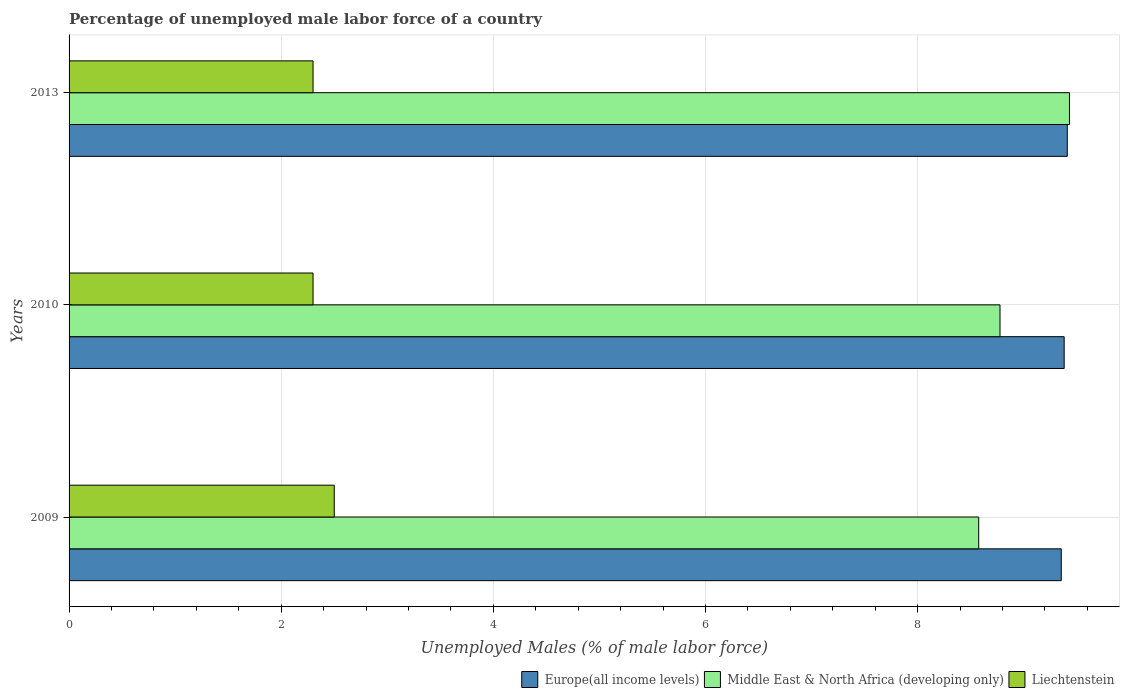How many groups of bars are there?
Offer a terse response. 3. Are the number of bars per tick equal to the number of legend labels?
Provide a succinct answer. Yes. Are the number of bars on each tick of the Y-axis equal?
Ensure brevity in your answer.  Yes. How many bars are there on the 3rd tick from the bottom?
Ensure brevity in your answer.  3. In how many cases, is the number of bars for a given year not equal to the number of legend labels?
Offer a very short reply. 0. What is the percentage of unemployed male labor force in Europe(all income levels) in 2010?
Make the answer very short. 9.38. Across all years, what is the maximum percentage of unemployed male labor force in Middle East & North Africa (developing only)?
Provide a succinct answer. 9.43. Across all years, what is the minimum percentage of unemployed male labor force in Europe(all income levels)?
Your answer should be compact. 9.35. In which year was the percentage of unemployed male labor force in Middle East & North Africa (developing only) minimum?
Provide a succinct answer. 2009. What is the total percentage of unemployed male labor force in Europe(all income levels) in the graph?
Make the answer very short. 28.14. What is the difference between the percentage of unemployed male labor force in Middle East & North Africa (developing only) in 2010 and that in 2013?
Offer a very short reply. -0.65. What is the difference between the percentage of unemployed male labor force in Middle East & North Africa (developing only) in 2010 and the percentage of unemployed male labor force in Europe(all income levels) in 2013?
Ensure brevity in your answer.  -0.63. What is the average percentage of unemployed male labor force in Liechtenstein per year?
Make the answer very short. 2.37. In the year 2010, what is the difference between the percentage of unemployed male labor force in Europe(all income levels) and percentage of unemployed male labor force in Middle East & North Africa (developing only)?
Your answer should be compact. 0.61. What is the ratio of the percentage of unemployed male labor force in Europe(all income levels) in 2009 to that in 2010?
Your answer should be compact. 1. Is the percentage of unemployed male labor force in Europe(all income levels) in 2010 less than that in 2013?
Provide a short and direct response. Yes. Is the difference between the percentage of unemployed male labor force in Europe(all income levels) in 2010 and 2013 greater than the difference between the percentage of unemployed male labor force in Middle East & North Africa (developing only) in 2010 and 2013?
Your answer should be very brief. Yes. What is the difference between the highest and the second highest percentage of unemployed male labor force in Middle East & North Africa (developing only)?
Ensure brevity in your answer.  0.65. What is the difference between the highest and the lowest percentage of unemployed male labor force in Liechtenstein?
Your response must be concise. 0.2. What does the 2nd bar from the top in 2009 represents?
Provide a succinct answer. Middle East & North Africa (developing only). What does the 1st bar from the bottom in 2009 represents?
Offer a very short reply. Europe(all income levels). How many bars are there?
Ensure brevity in your answer.  9. How many years are there in the graph?
Provide a short and direct response. 3. Where does the legend appear in the graph?
Your answer should be compact. Bottom right. What is the title of the graph?
Offer a terse response. Percentage of unemployed male labor force of a country. What is the label or title of the X-axis?
Provide a succinct answer. Unemployed Males (% of male labor force). What is the Unemployed Males (% of male labor force) of Europe(all income levels) in 2009?
Provide a succinct answer. 9.35. What is the Unemployed Males (% of male labor force) in Middle East & North Africa (developing only) in 2009?
Your response must be concise. 8.58. What is the Unemployed Males (% of male labor force) in Liechtenstein in 2009?
Your answer should be very brief. 2.5. What is the Unemployed Males (% of male labor force) in Europe(all income levels) in 2010?
Your answer should be compact. 9.38. What is the Unemployed Males (% of male labor force) in Middle East & North Africa (developing only) in 2010?
Give a very brief answer. 8.78. What is the Unemployed Males (% of male labor force) in Liechtenstein in 2010?
Provide a succinct answer. 2.3. What is the Unemployed Males (% of male labor force) in Europe(all income levels) in 2013?
Your answer should be compact. 9.41. What is the Unemployed Males (% of male labor force) of Middle East & North Africa (developing only) in 2013?
Make the answer very short. 9.43. What is the Unemployed Males (% of male labor force) of Liechtenstein in 2013?
Provide a short and direct response. 2.3. Across all years, what is the maximum Unemployed Males (% of male labor force) of Europe(all income levels)?
Give a very brief answer. 9.41. Across all years, what is the maximum Unemployed Males (% of male labor force) in Middle East & North Africa (developing only)?
Provide a succinct answer. 9.43. Across all years, what is the minimum Unemployed Males (% of male labor force) of Europe(all income levels)?
Give a very brief answer. 9.35. Across all years, what is the minimum Unemployed Males (% of male labor force) of Middle East & North Africa (developing only)?
Give a very brief answer. 8.58. Across all years, what is the minimum Unemployed Males (% of male labor force) of Liechtenstein?
Provide a succinct answer. 2.3. What is the total Unemployed Males (% of male labor force) of Europe(all income levels) in the graph?
Your answer should be compact. 28.14. What is the total Unemployed Males (% of male labor force) of Middle East & North Africa (developing only) in the graph?
Provide a short and direct response. 26.78. What is the total Unemployed Males (% of male labor force) of Liechtenstein in the graph?
Keep it short and to the point. 7.1. What is the difference between the Unemployed Males (% of male labor force) in Europe(all income levels) in 2009 and that in 2010?
Keep it short and to the point. -0.03. What is the difference between the Unemployed Males (% of male labor force) of Middle East & North Africa (developing only) in 2009 and that in 2010?
Offer a very short reply. -0.2. What is the difference between the Unemployed Males (% of male labor force) in Liechtenstein in 2009 and that in 2010?
Offer a terse response. 0.2. What is the difference between the Unemployed Males (% of male labor force) of Europe(all income levels) in 2009 and that in 2013?
Ensure brevity in your answer.  -0.06. What is the difference between the Unemployed Males (% of male labor force) of Middle East & North Africa (developing only) in 2009 and that in 2013?
Provide a succinct answer. -0.86. What is the difference between the Unemployed Males (% of male labor force) in Europe(all income levels) in 2010 and that in 2013?
Your response must be concise. -0.03. What is the difference between the Unemployed Males (% of male labor force) in Middle East & North Africa (developing only) in 2010 and that in 2013?
Your response must be concise. -0.66. What is the difference between the Unemployed Males (% of male labor force) in Liechtenstein in 2010 and that in 2013?
Offer a terse response. 0. What is the difference between the Unemployed Males (% of male labor force) in Europe(all income levels) in 2009 and the Unemployed Males (% of male labor force) in Middle East & North Africa (developing only) in 2010?
Make the answer very short. 0.58. What is the difference between the Unemployed Males (% of male labor force) of Europe(all income levels) in 2009 and the Unemployed Males (% of male labor force) of Liechtenstein in 2010?
Your answer should be compact. 7.05. What is the difference between the Unemployed Males (% of male labor force) in Middle East & North Africa (developing only) in 2009 and the Unemployed Males (% of male labor force) in Liechtenstein in 2010?
Provide a short and direct response. 6.28. What is the difference between the Unemployed Males (% of male labor force) of Europe(all income levels) in 2009 and the Unemployed Males (% of male labor force) of Middle East & North Africa (developing only) in 2013?
Provide a succinct answer. -0.08. What is the difference between the Unemployed Males (% of male labor force) of Europe(all income levels) in 2009 and the Unemployed Males (% of male labor force) of Liechtenstein in 2013?
Give a very brief answer. 7.05. What is the difference between the Unemployed Males (% of male labor force) in Middle East & North Africa (developing only) in 2009 and the Unemployed Males (% of male labor force) in Liechtenstein in 2013?
Your answer should be very brief. 6.28. What is the difference between the Unemployed Males (% of male labor force) of Europe(all income levels) in 2010 and the Unemployed Males (% of male labor force) of Middle East & North Africa (developing only) in 2013?
Offer a terse response. -0.05. What is the difference between the Unemployed Males (% of male labor force) of Europe(all income levels) in 2010 and the Unemployed Males (% of male labor force) of Liechtenstein in 2013?
Make the answer very short. 7.08. What is the difference between the Unemployed Males (% of male labor force) in Middle East & North Africa (developing only) in 2010 and the Unemployed Males (% of male labor force) in Liechtenstein in 2013?
Your answer should be compact. 6.48. What is the average Unemployed Males (% of male labor force) in Europe(all income levels) per year?
Your response must be concise. 9.38. What is the average Unemployed Males (% of male labor force) of Middle East & North Africa (developing only) per year?
Give a very brief answer. 8.93. What is the average Unemployed Males (% of male labor force) of Liechtenstein per year?
Keep it short and to the point. 2.37. In the year 2009, what is the difference between the Unemployed Males (% of male labor force) of Europe(all income levels) and Unemployed Males (% of male labor force) of Middle East & North Africa (developing only)?
Provide a short and direct response. 0.78. In the year 2009, what is the difference between the Unemployed Males (% of male labor force) in Europe(all income levels) and Unemployed Males (% of male labor force) in Liechtenstein?
Your response must be concise. 6.85. In the year 2009, what is the difference between the Unemployed Males (% of male labor force) of Middle East & North Africa (developing only) and Unemployed Males (% of male labor force) of Liechtenstein?
Your answer should be very brief. 6.08. In the year 2010, what is the difference between the Unemployed Males (% of male labor force) in Europe(all income levels) and Unemployed Males (% of male labor force) in Middle East & North Africa (developing only)?
Your response must be concise. 0.6. In the year 2010, what is the difference between the Unemployed Males (% of male labor force) of Europe(all income levels) and Unemployed Males (% of male labor force) of Liechtenstein?
Ensure brevity in your answer.  7.08. In the year 2010, what is the difference between the Unemployed Males (% of male labor force) of Middle East & North Africa (developing only) and Unemployed Males (% of male labor force) of Liechtenstein?
Your response must be concise. 6.48. In the year 2013, what is the difference between the Unemployed Males (% of male labor force) in Europe(all income levels) and Unemployed Males (% of male labor force) in Middle East & North Africa (developing only)?
Your answer should be very brief. -0.02. In the year 2013, what is the difference between the Unemployed Males (% of male labor force) in Europe(all income levels) and Unemployed Males (% of male labor force) in Liechtenstein?
Give a very brief answer. 7.11. In the year 2013, what is the difference between the Unemployed Males (% of male labor force) of Middle East & North Africa (developing only) and Unemployed Males (% of male labor force) of Liechtenstein?
Make the answer very short. 7.13. What is the ratio of the Unemployed Males (% of male labor force) of Middle East & North Africa (developing only) in 2009 to that in 2010?
Your response must be concise. 0.98. What is the ratio of the Unemployed Males (% of male labor force) of Liechtenstein in 2009 to that in 2010?
Make the answer very short. 1.09. What is the ratio of the Unemployed Males (% of male labor force) of Middle East & North Africa (developing only) in 2009 to that in 2013?
Provide a succinct answer. 0.91. What is the ratio of the Unemployed Males (% of male labor force) in Liechtenstein in 2009 to that in 2013?
Provide a succinct answer. 1.09. What is the ratio of the Unemployed Males (% of male labor force) of Europe(all income levels) in 2010 to that in 2013?
Keep it short and to the point. 1. What is the ratio of the Unemployed Males (% of male labor force) of Middle East & North Africa (developing only) in 2010 to that in 2013?
Offer a terse response. 0.93. What is the ratio of the Unemployed Males (% of male labor force) in Liechtenstein in 2010 to that in 2013?
Provide a succinct answer. 1. What is the difference between the highest and the second highest Unemployed Males (% of male labor force) of Europe(all income levels)?
Offer a very short reply. 0.03. What is the difference between the highest and the second highest Unemployed Males (% of male labor force) of Middle East & North Africa (developing only)?
Make the answer very short. 0.66. What is the difference between the highest and the second highest Unemployed Males (% of male labor force) in Liechtenstein?
Keep it short and to the point. 0.2. What is the difference between the highest and the lowest Unemployed Males (% of male labor force) in Europe(all income levels)?
Your answer should be very brief. 0.06. What is the difference between the highest and the lowest Unemployed Males (% of male labor force) of Middle East & North Africa (developing only)?
Keep it short and to the point. 0.86. What is the difference between the highest and the lowest Unemployed Males (% of male labor force) in Liechtenstein?
Offer a very short reply. 0.2. 